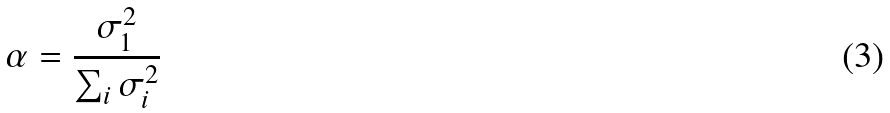Convert formula to latex. <formula><loc_0><loc_0><loc_500><loc_500>\alpha = \frac { \sigma _ { 1 } ^ { 2 } } { \sum _ { i } \sigma _ { i } ^ { 2 } }</formula> 